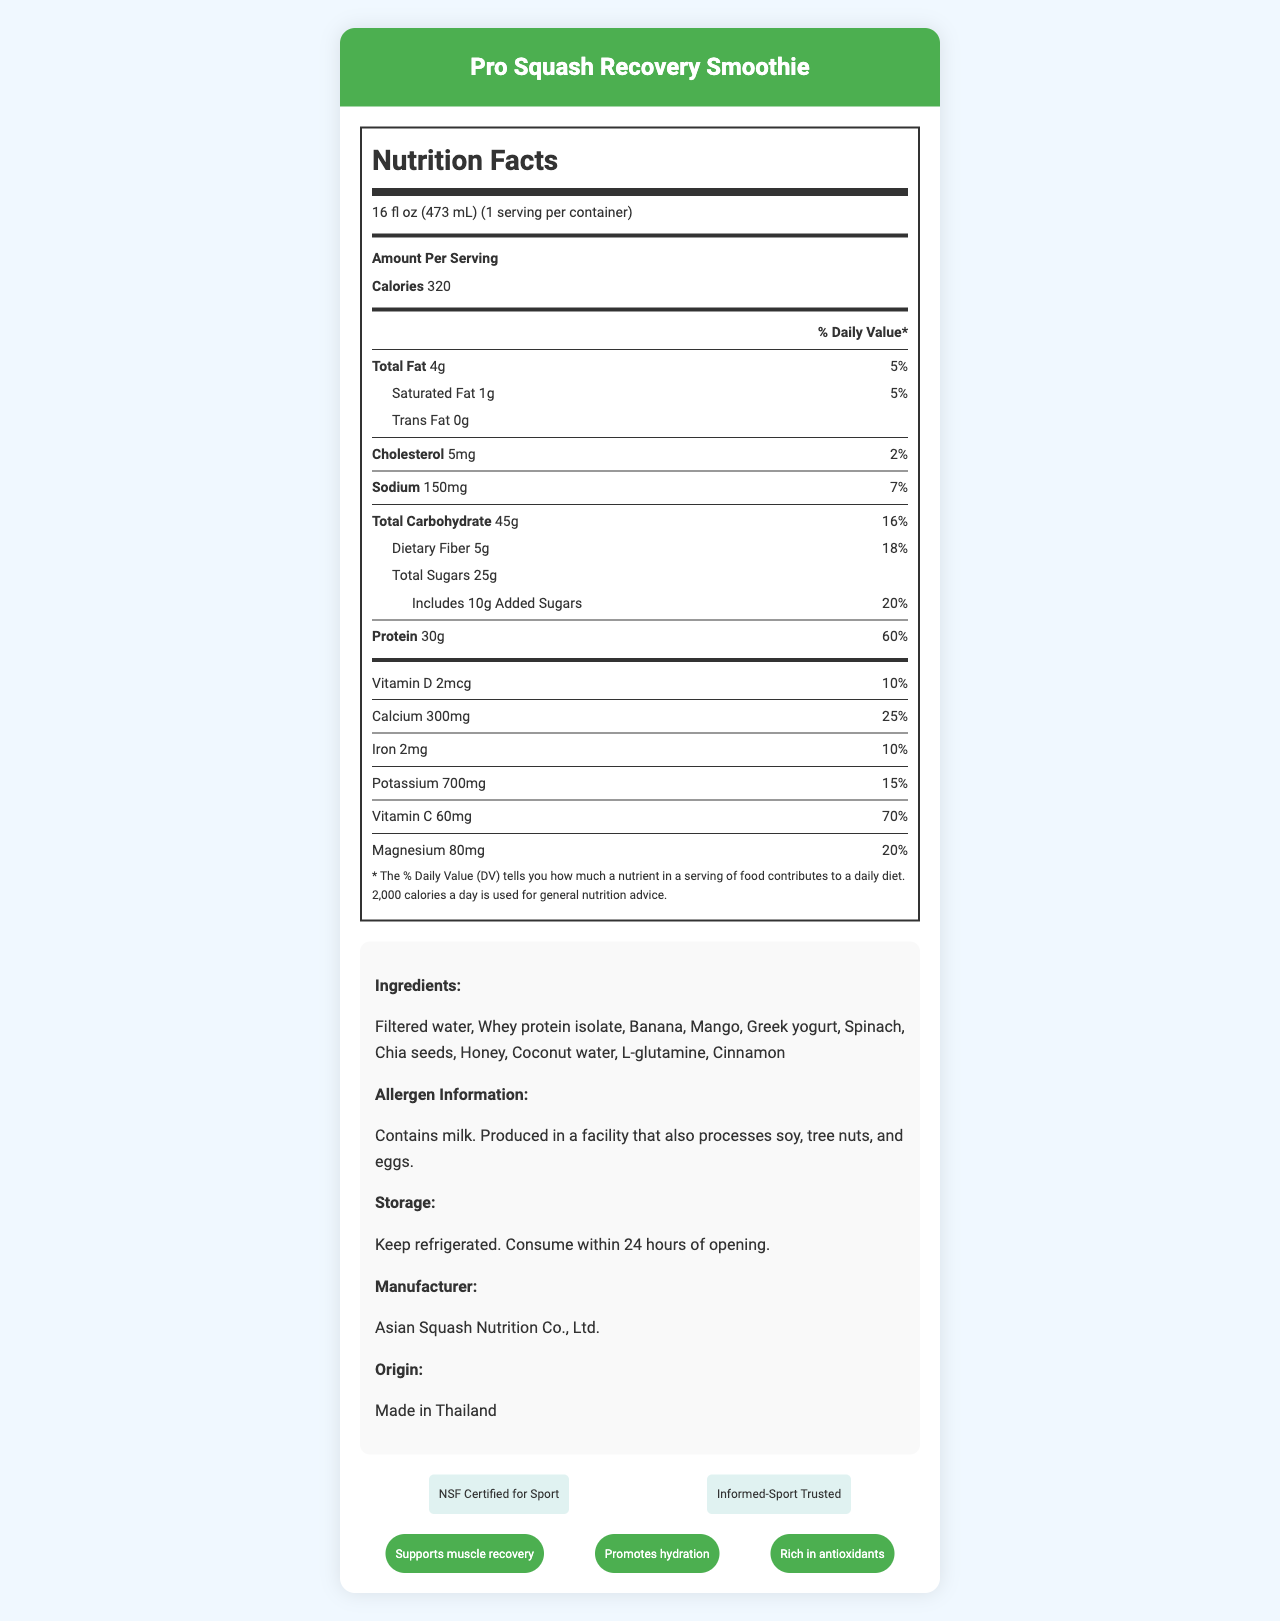what is the serving size of the Pro Squash Recovery Smoothie? The serving size is explicitly stated at the beginning of the Nutrition Facts section of the document.
Answer: 16 fl oz (473 mL) how many grams of protein does one serving of the smoothie contain? The amount of protein per serving is listed under the "Protein" section of the Nutrition Facts.
Answer: 30g what percentage of the daily value does the sodium content represent? The sodium content's daily value percentage is presented with the sodium amount in the Nutrition Facts.
Answer: 7% how much added sugars does the smoothie include? The amount of added sugars is indicated under the "Total Sugars" section in the Nutrition Facts.
Answer: 10g which vitamin has the highest percentage of daily value? The Vitamin C content has a daily value percentage of 70%, which is the highest among the vitamins listed.
Answer: Vitamin C what are the main ingredients in the smoothie? The ingredients are listed under the "Ingredients" section of the document.
Answer: Filtered water, Whey protein isolate, Banana, Mango, Greek yogurt, Spinach, Chia seeds, Honey, Coconut water, L-glutamine, Cinnamon where is the Pro Squash Recovery Smoothie manufactured? A. China B. Japan C. Thailand D. India The "Origin" section of the document states that the smoothie is made in Thailand.
Answer: C. Thailand which certification does the product have? I. Kosher Certified II. NSF Certified for Sport III. Organic IV. Informed-Sport Trusted The certifications listed are "NSF Certified for Sport" and "Informed-Sport Trusted."
Answer: II. NSF Certified for Sport and IV. Informed-Sport Trusted is the Pro Squash Recovery Smoothie lactose-free? The allergen information clearly states that the product contains milk, which means it is not lactose-free.
Answer: No how should the smoothie be stored after opening? The storage instructions explicitly state the need for refrigeration and consumption within 24 hours.
Answer: Keep refrigerated. Consume within 24 hours of opening. describe the main idea of the document The label provides detailed information about the nutrition, ingredients, and other relevant details for someone interested in consuming the Pro Squash Recovery Smoothie.
Answer: The document is a Nutrition Facts Label for the Pro Squash Recovery Smoothie, highlighting its nutritional content, ingredients, allergen information, storage instructions, manufacturer, origin, certifications, and health claims. how much caffeine is in the smoothie? The document does not provide any information regarding the presence or absence of caffeine in the smoothie.
Answer: Cannot be determined 